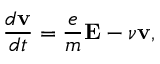Convert formula to latex. <formula><loc_0><loc_0><loc_500><loc_500>{ \frac { d { v } } { d t } } = { \frac { e } { m } } E - \nu v ,</formula> 